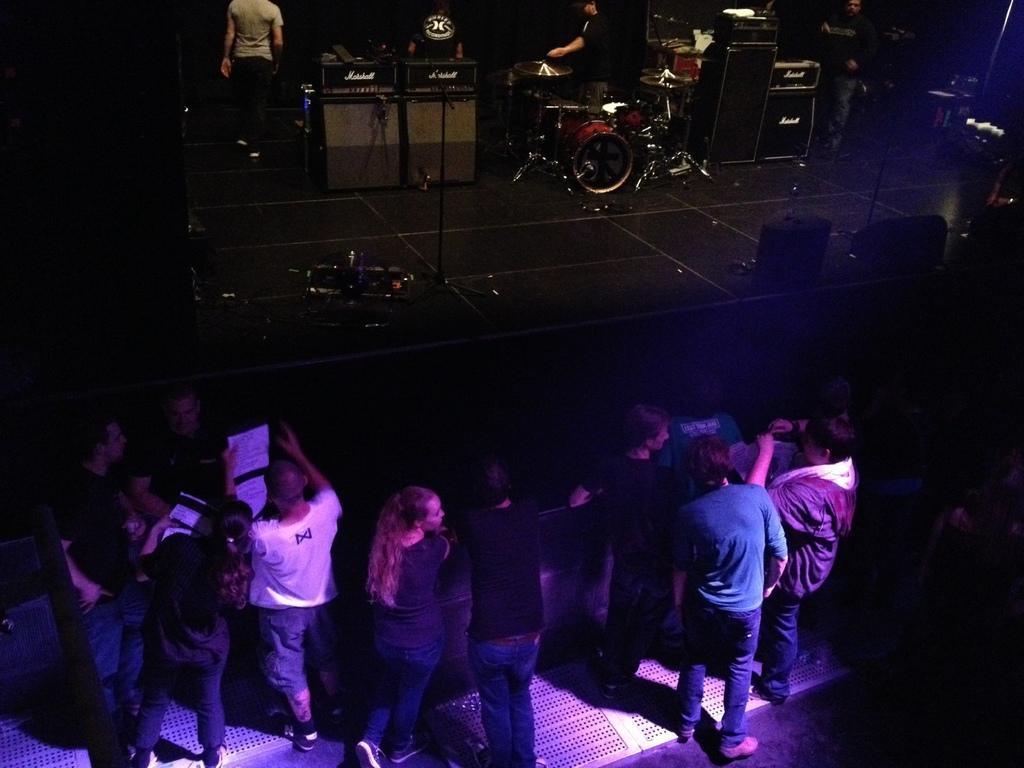Please provide a concise description of this image. Background portion of the picture is dark. In this picture we can see the people, musical instruments, devices, stands and few objects. We can see a platform. At the bottom portion of the picture we can see the people standing on the floor. We can see the papers. 